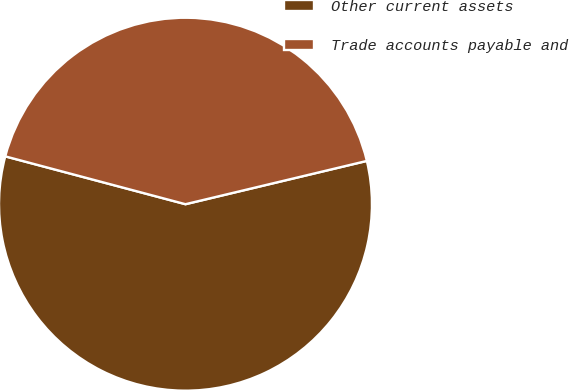Convert chart. <chart><loc_0><loc_0><loc_500><loc_500><pie_chart><fcel>Other current assets<fcel>Trade accounts payable and<nl><fcel>57.86%<fcel>42.14%<nl></chart> 